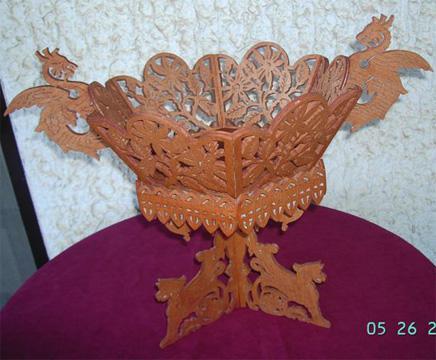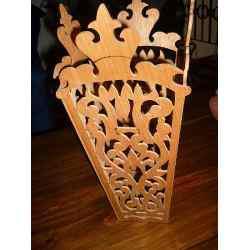The first image is the image on the left, the second image is the image on the right. Examine the images to the left and right. Is the description "Two wooden filigree stands, one larger than the other, have a cylindrical upper section with four handles, sitting on a base with four corresponding legs." accurate? Answer yes or no. No. The first image is the image on the left, the second image is the image on the right. For the images displayed, is the sentence "There is a set of vases with differing heights in the image on the left." factually correct? Answer yes or no. No. 